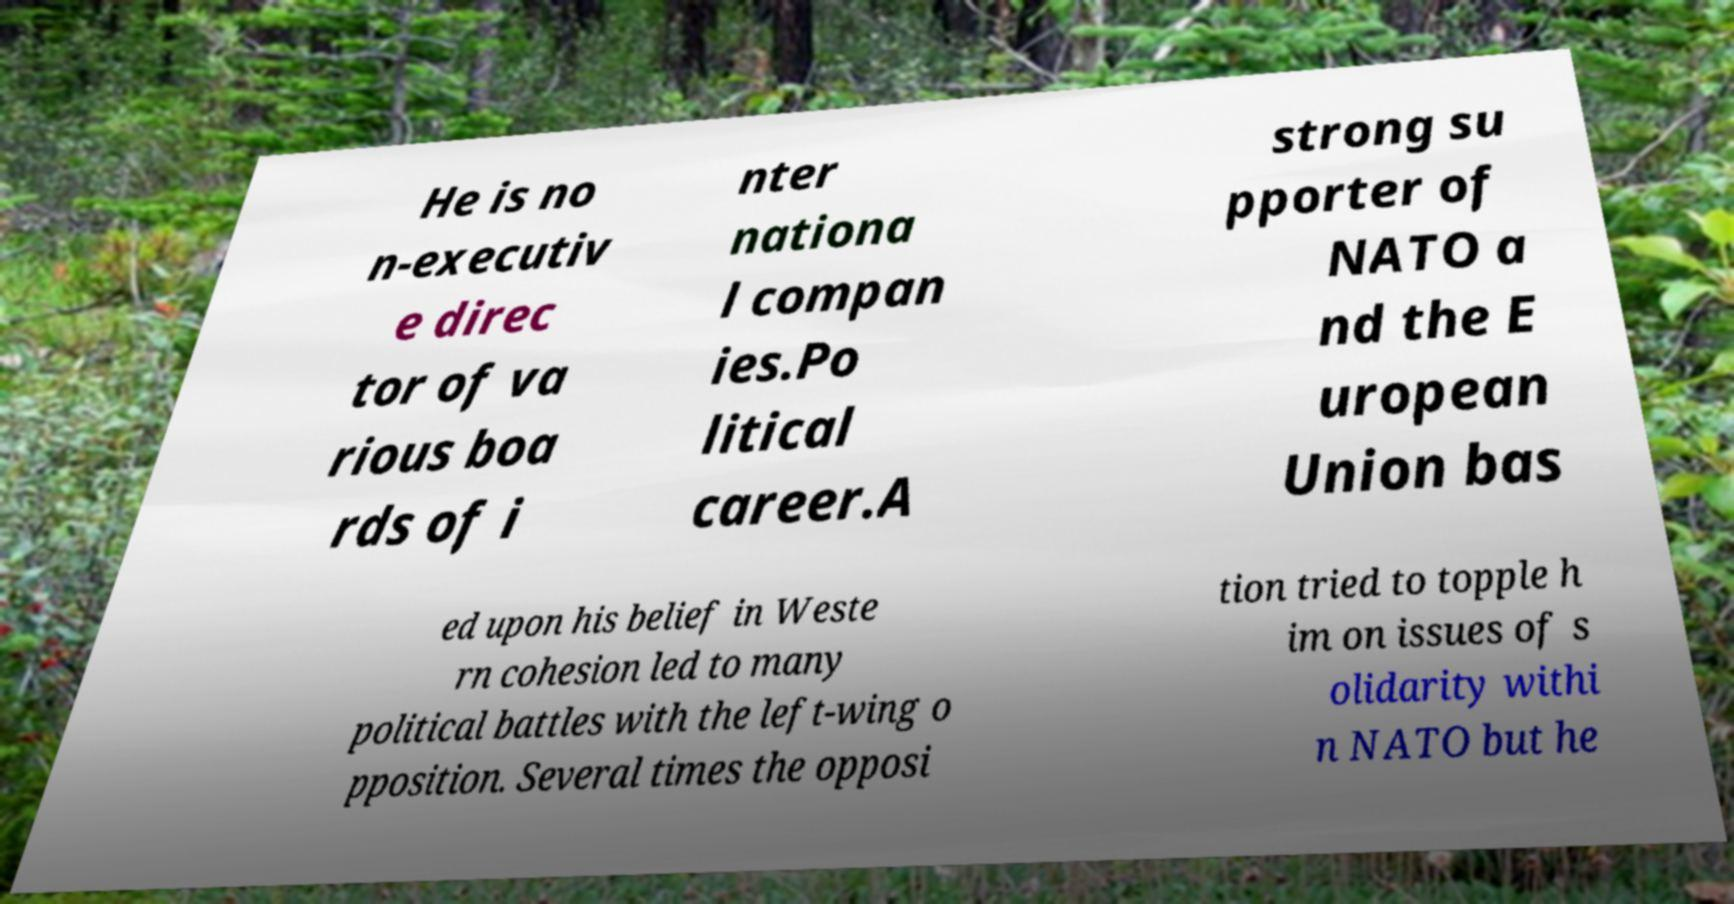Could you extract and type out the text from this image? He is no n-executiv e direc tor of va rious boa rds of i nter nationa l compan ies.Po litical career.A strong su pporter of NATO a nd the E uropean Union bas ed upon his belief in Weste rn cohesion led to many political battles with the left-wing o pposition. Several times the opposi tion tried to topple h im on issues of s olidarity withi n NATO but he 